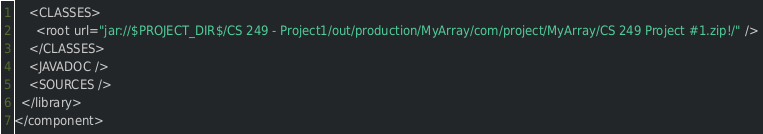Convert code to text. <code><loc_0><loc_0><loc_500><loc_500><_XML_>    <CLASSES>
      <root url="jar://$PROJECT_DIR$/CS 249 - Project1/out/production/MyArray/com/project/MyArray/CS 249 Project #1.zip!/" />
    </CLASSES>
    <JAVADOC />
    <SOURCES />
  </library>
</component></code> 